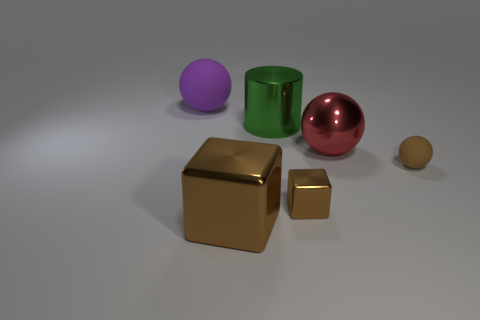What is the size of the other rubber object that is the same shape as the tiny rubber thing?
Make the answer very short. Large. What number of large green metallic balls are there?
Offer a very short reply. 0. There is a big red metallic object; is its shape the same as the shiny object that is on the left side of the cylinder?
Make the answer very short. No. There is a rubber sphere that is behind the small matte object; how big is it?
Provide a succinct answer. Large. What is the material of the large cube?
Give a very brief answer. Metal. Does the small thing on the right side of the red ball have the same shape as the large green metallic object?
Make the answer very short. No. What is the size of the rubber sphere that is the same color as the large block?
Make the answer very short. Small. Is there another thing that has the same size as the green object?
Make the answer very short. Yes. There is a rubber thing that is in front of the large sphere that is behind the big metallic cylinder; are there any big metal cylinders that are right of it?
Keep it short and to the point. No. Is the color of the tiny shiny thing the same as the rubber ball in front of the purple matte object?
Your response must be concise. Yes. 